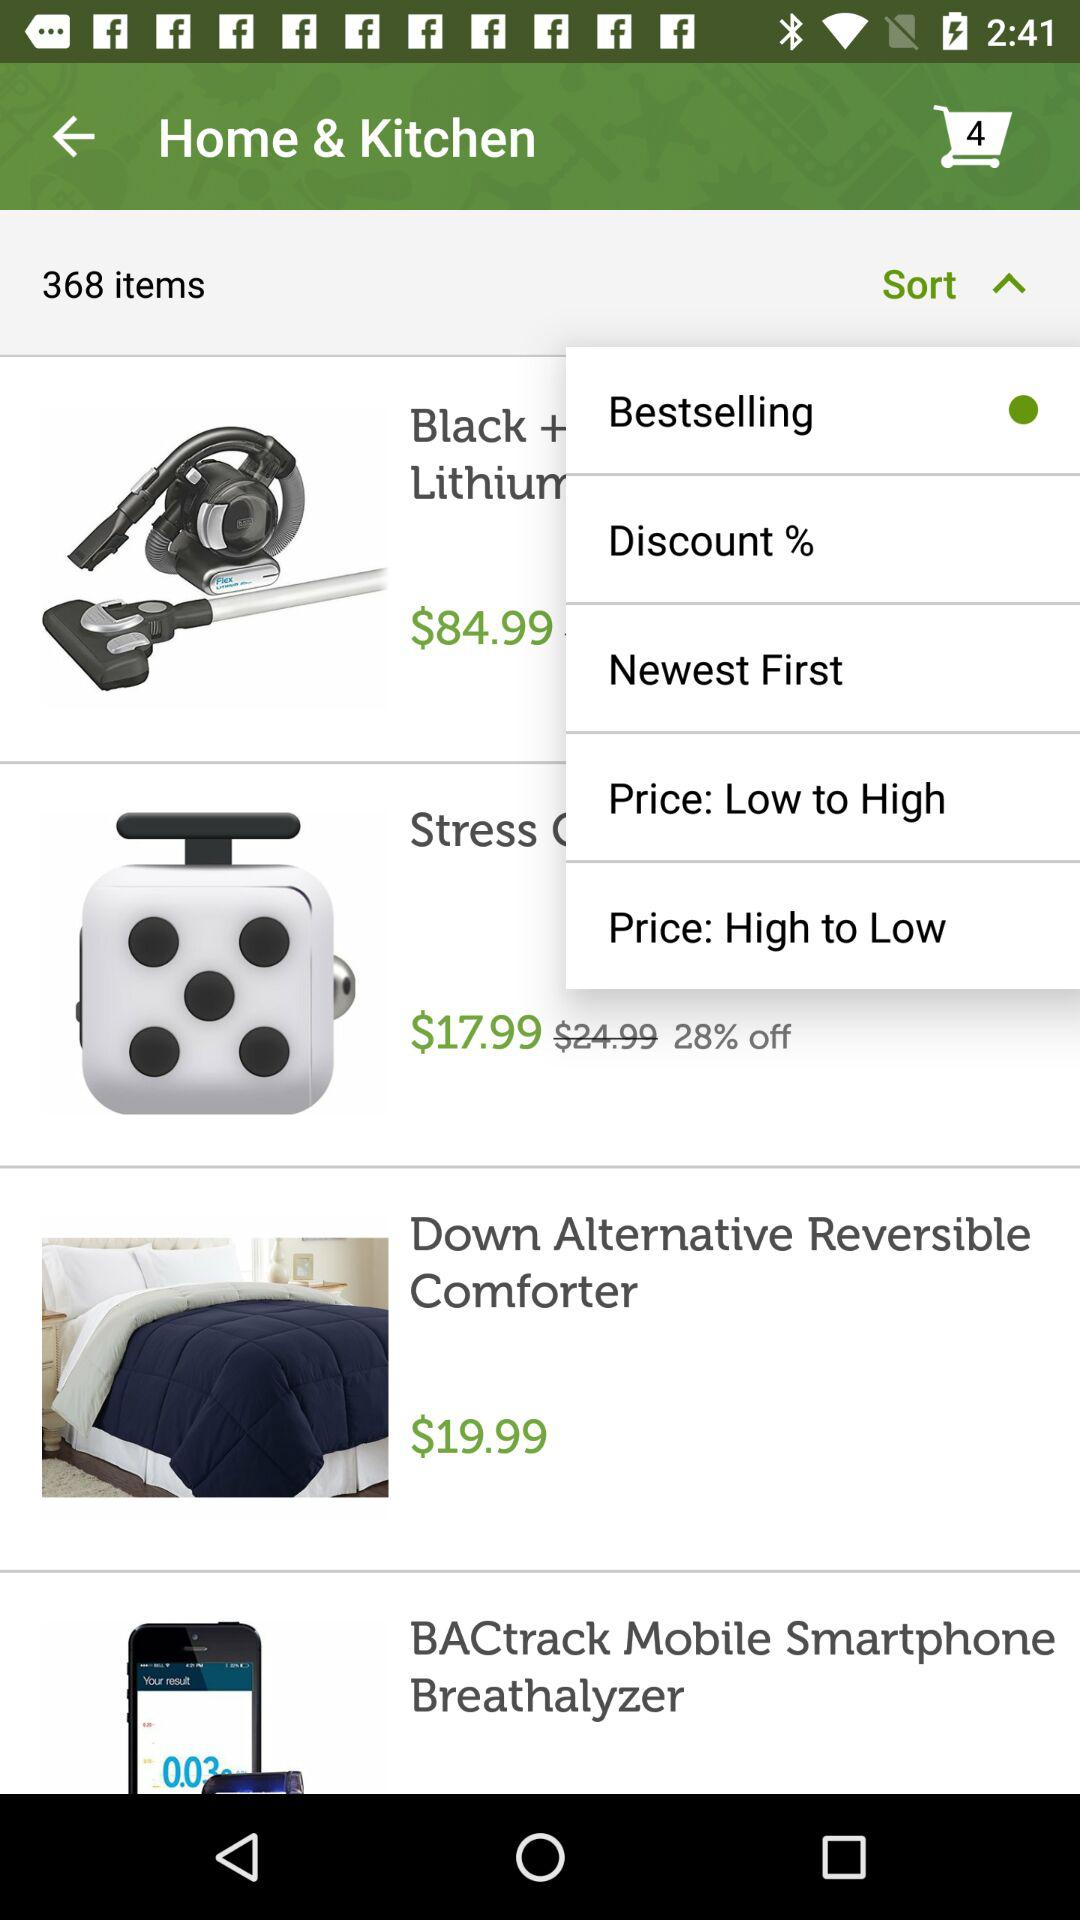How many items in total are there? There are 368 items in total. 